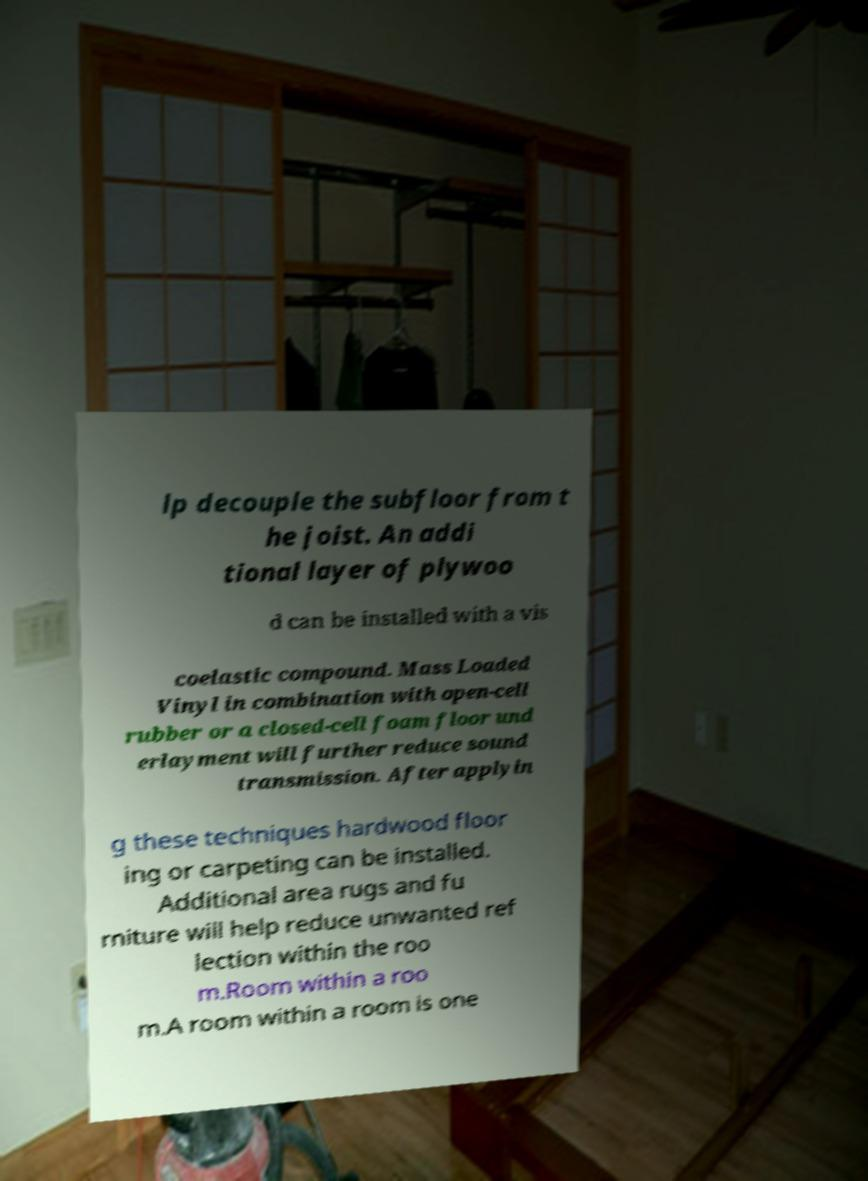Could you extract and type out the text from this image? lp decouple the subfloor from t he joist. An addi tional layer of plywoo d can be installed with a vis coelastic compound. Mass Loaded Vinyl in combination with open-cell rubber or a closed-cell foam floor und erlayment will further reduce sound transmission. After applyin g these techniques hardwood floor ing or carpeting can be installed. Additional area rugs and fu rniture will help reduce unwanted ref lection within the roo m.Room within a roo m.A room within a room is one 